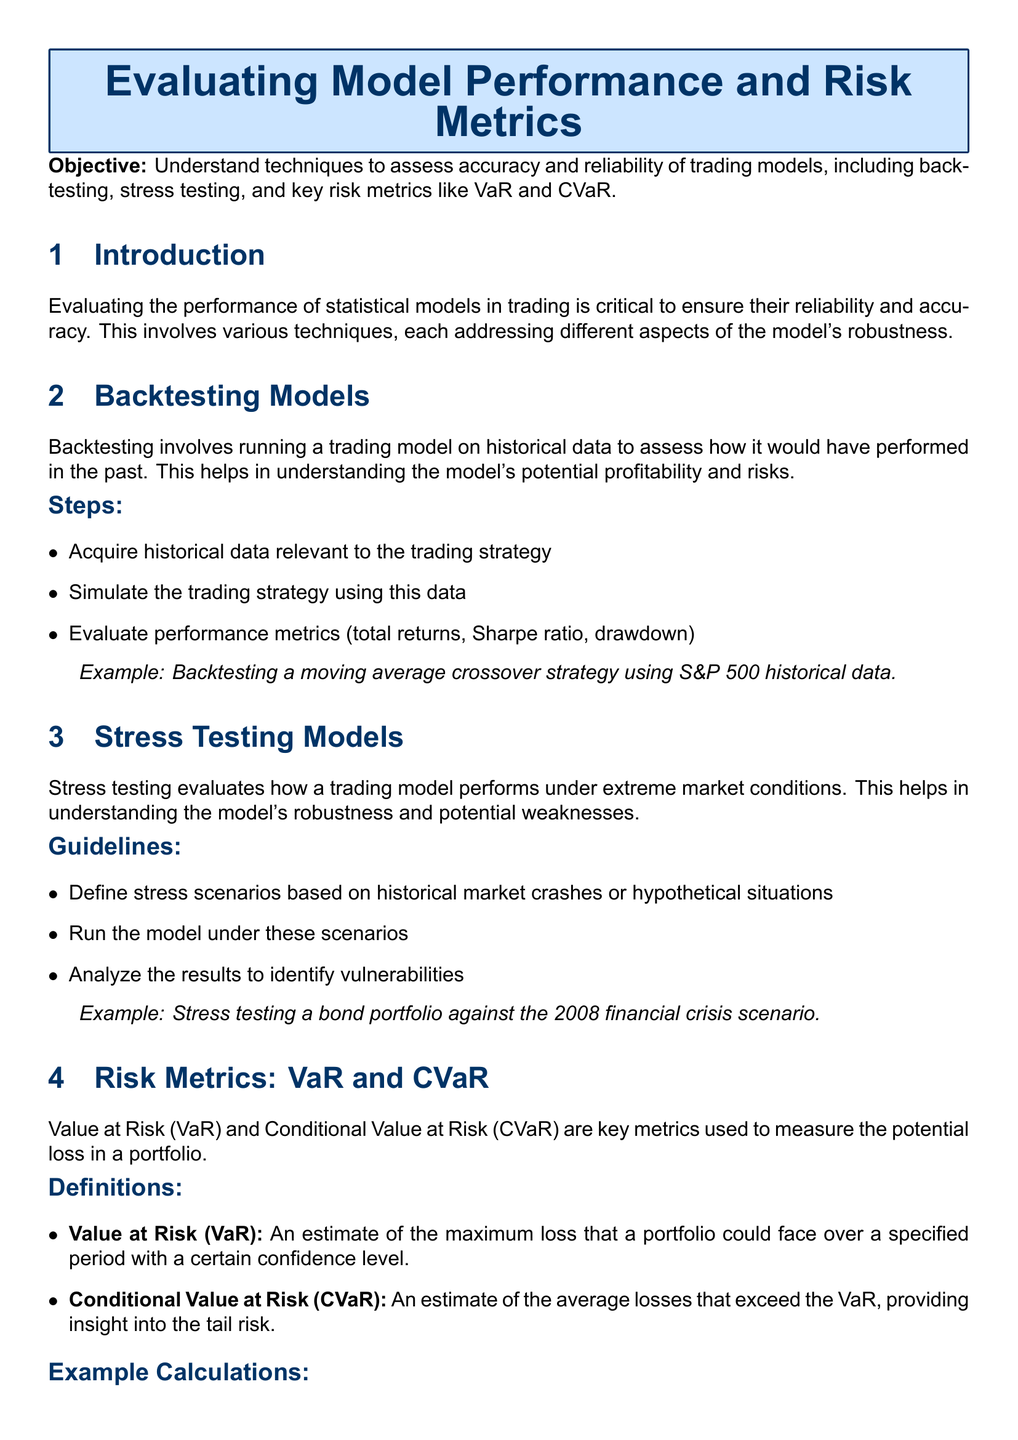What is the objective of the lesson? The objective is to understand techniques to assess accuracy and reliability of trading models, including backtesting, stress testing, and key risk metrics like VaR and CVaR.
Answer: understand techniques to assess accuracy and reliability of trading models What is backtesting? Backtesting involves running a trading model on historical data to assess how it would have performed in the past.
Answer: running a trading model on historical data What are the performance metrics mentioned for evaluation? The performance metrics include total returns, Sharpe ratio, and drawdown.
Answer: total returns, Sharpe ratio, drawdown Define Value at Risk (VaR). Value at Risk (VaR) is an estimate of the maximum loss that a portfolio could face over a specified period with a certain confidence level.
Answer: maximum loss that a portfolio could face over a specified period with a certain confidence level What stress testing evaluates? Stress testing evaluates how a trading model performs under extreme market conditions.
Answer: how a trading model performs under extreme market conditions What is the example scenario used in stress testing? The example scenario is stress testing a bond portfolio against the 2008 financial crisis scenario.
Answer: stress testing a bond portfolio against the 2008 financial crisis scenario What does CVaR provide insight into? CVaR provides insight into the tail risk.
Answer: tail risk What are the two risk metrics discussed? The two risk metrics discussed are Value at Risk (VaR) and Conditional Value at Risk (CVaR).
Answer: Value at Risk (VaR) and Conditional Value at Risk (CVaR) How does the lesson conclude? The conclusion emphasizes that evaluating model performance through various techniques is essential for robust risk management in trading strategies.
Answer: essential for robust risk management in trading strategies 